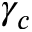<formula> <loc_0><loc_0><loc_500><loc_500>\gamma _ { c }</formula> 